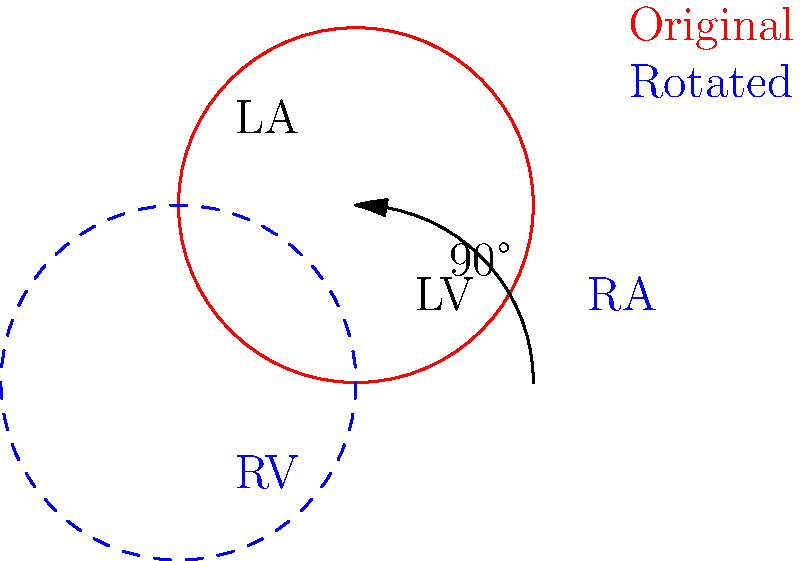In the diagram, a 2D cross-section of the heart is shown in red, with the left atrium (LA) and left ventricle (LV) labeled. If this cross-section is rotated 90° clockwise around the center point, which chamber will occupy the position originally held by the left atrium? To solve this problem, we need to follow these steps:

1. Understand the original orientation:
   - The red outline shows the original cross-section.
   - The left atrium (LA) is located in the upper left quadrant.
   - The left ventricle (LV) is located in the lower right quadrant.

2. Visualize the rotation:
   - The blue dashed outline shows the heart after a 90° clockwise rotation.
   - The rotation is indicated by the curved arrow in the diagram.

3. Analyze the new positions:
   - After rotation, the chamber that was originally at the top left (LA) will move to the top right.
   - The chamber that was originally at the bottom right (LV) will move to the bottom left.

4. Identify the chambers in the new orientation:
   - In a four-chamber view of the heart, the chambers are arranged as follows:
     * Left Atrium (LA) - upper left
     * Left Ventricle (LV) - lower left
     * Right Atrium (RA) - upper right
     * Right Ventricle (RV) - lower right

5. Determine the new position of the original LA:
   - The original LA position (upper left) has rotated to the upper right.
   - In the standard four-chamber view, the upper right position is occupied by the Right Atrium (RA).

Therefore, after the 90° clockwise rotation, the Right Atrium (RA) will occupy the position originally held by the Left Atrium (LA).
Answer: Right Atrium (RA) 